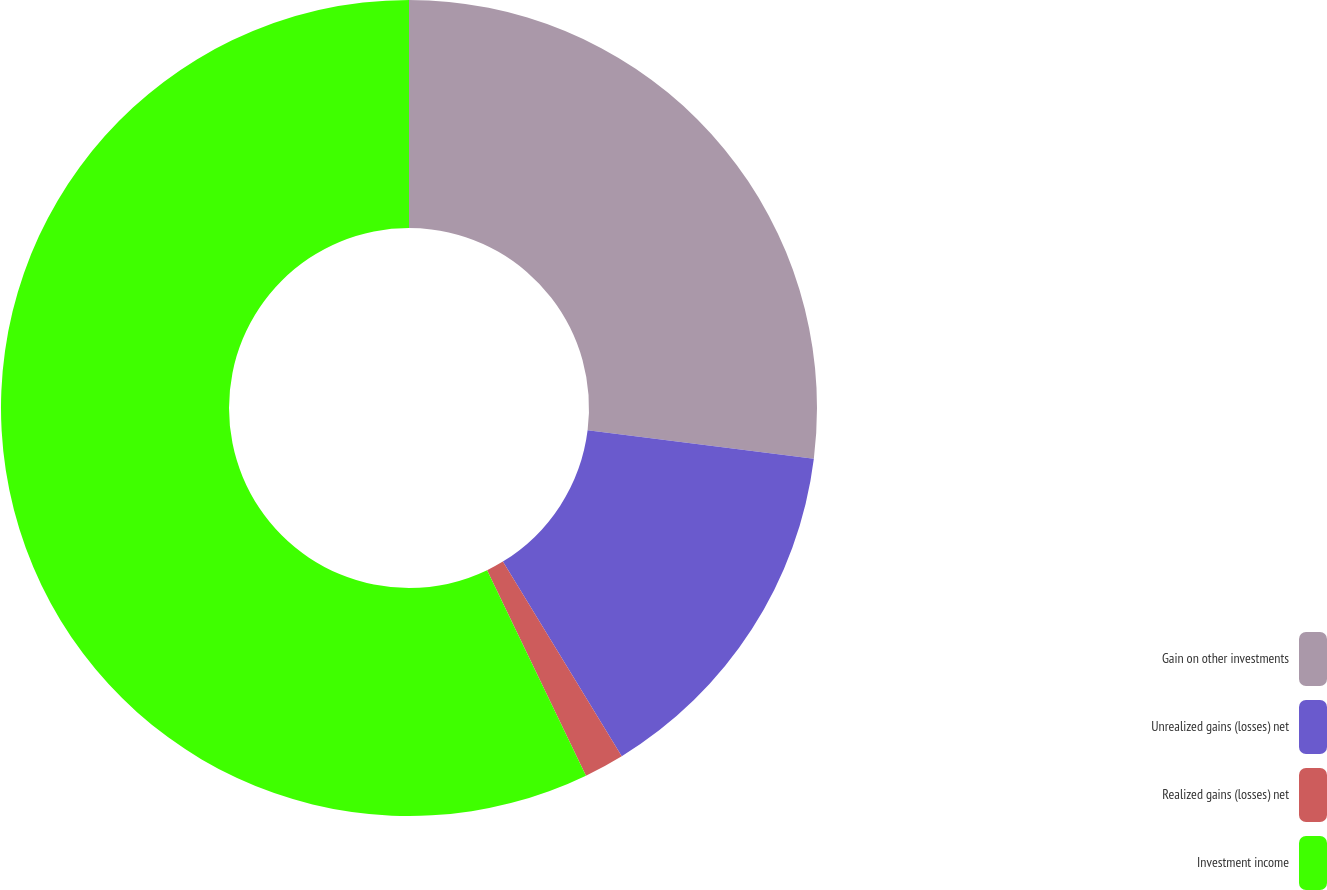Convert chart to OTSL. <chart><loc_0><loc_0><loc_500><loc_500><pie_chart><fcel>Gain on other investments<fcel>Unrealized gains (losses) net<fcel>Realized gains (losses) net<fcel>Investment income<nl><fcel>26.98%<fcel>14.29%<fcel>1.59%<fcel>57.14%<nl></chart> 